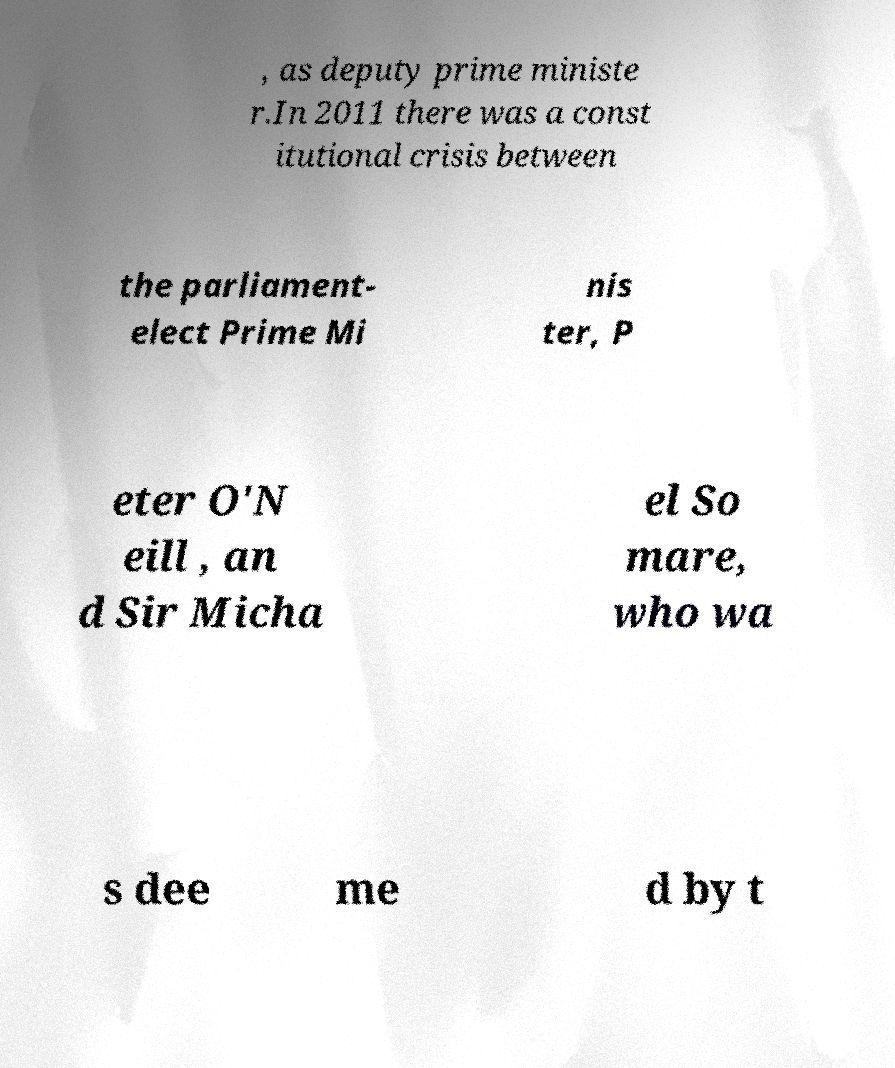Can you accurately transcribe the text from the provided image for me? , as deputy prime ministe r.In 2011 there was a const itutional crisis between the parliament- elect Prime Mi nis ter, P eter O'N eill , an d Sir Micha el So mare, who wa s dee me d by t 